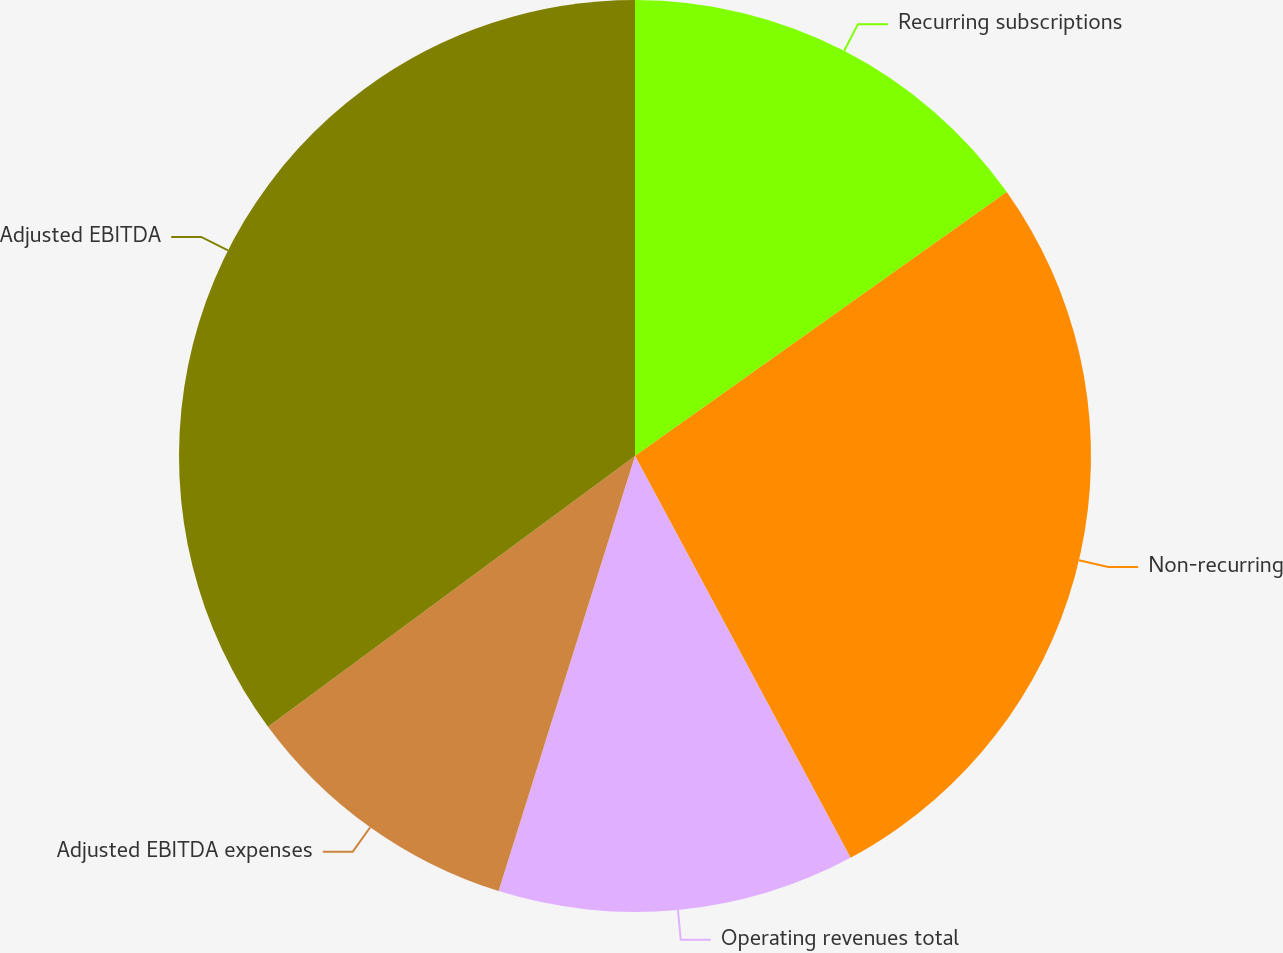Convert chart to OTSL. <chart><loc_0><loc_0><loc_500><loc_500><pie_chart><fcel>Recurring subscriptions<fcel>Non-recurring<fcel>Operating revenues total<fcel>Adjusted EBITDA expenses<fcel>Adjusted EBITDA<nl><fcel>15.17%<fcel>26.99%<fcel>12.67%<fcel>10.05%<fcel>35.11%<nl></chart> 